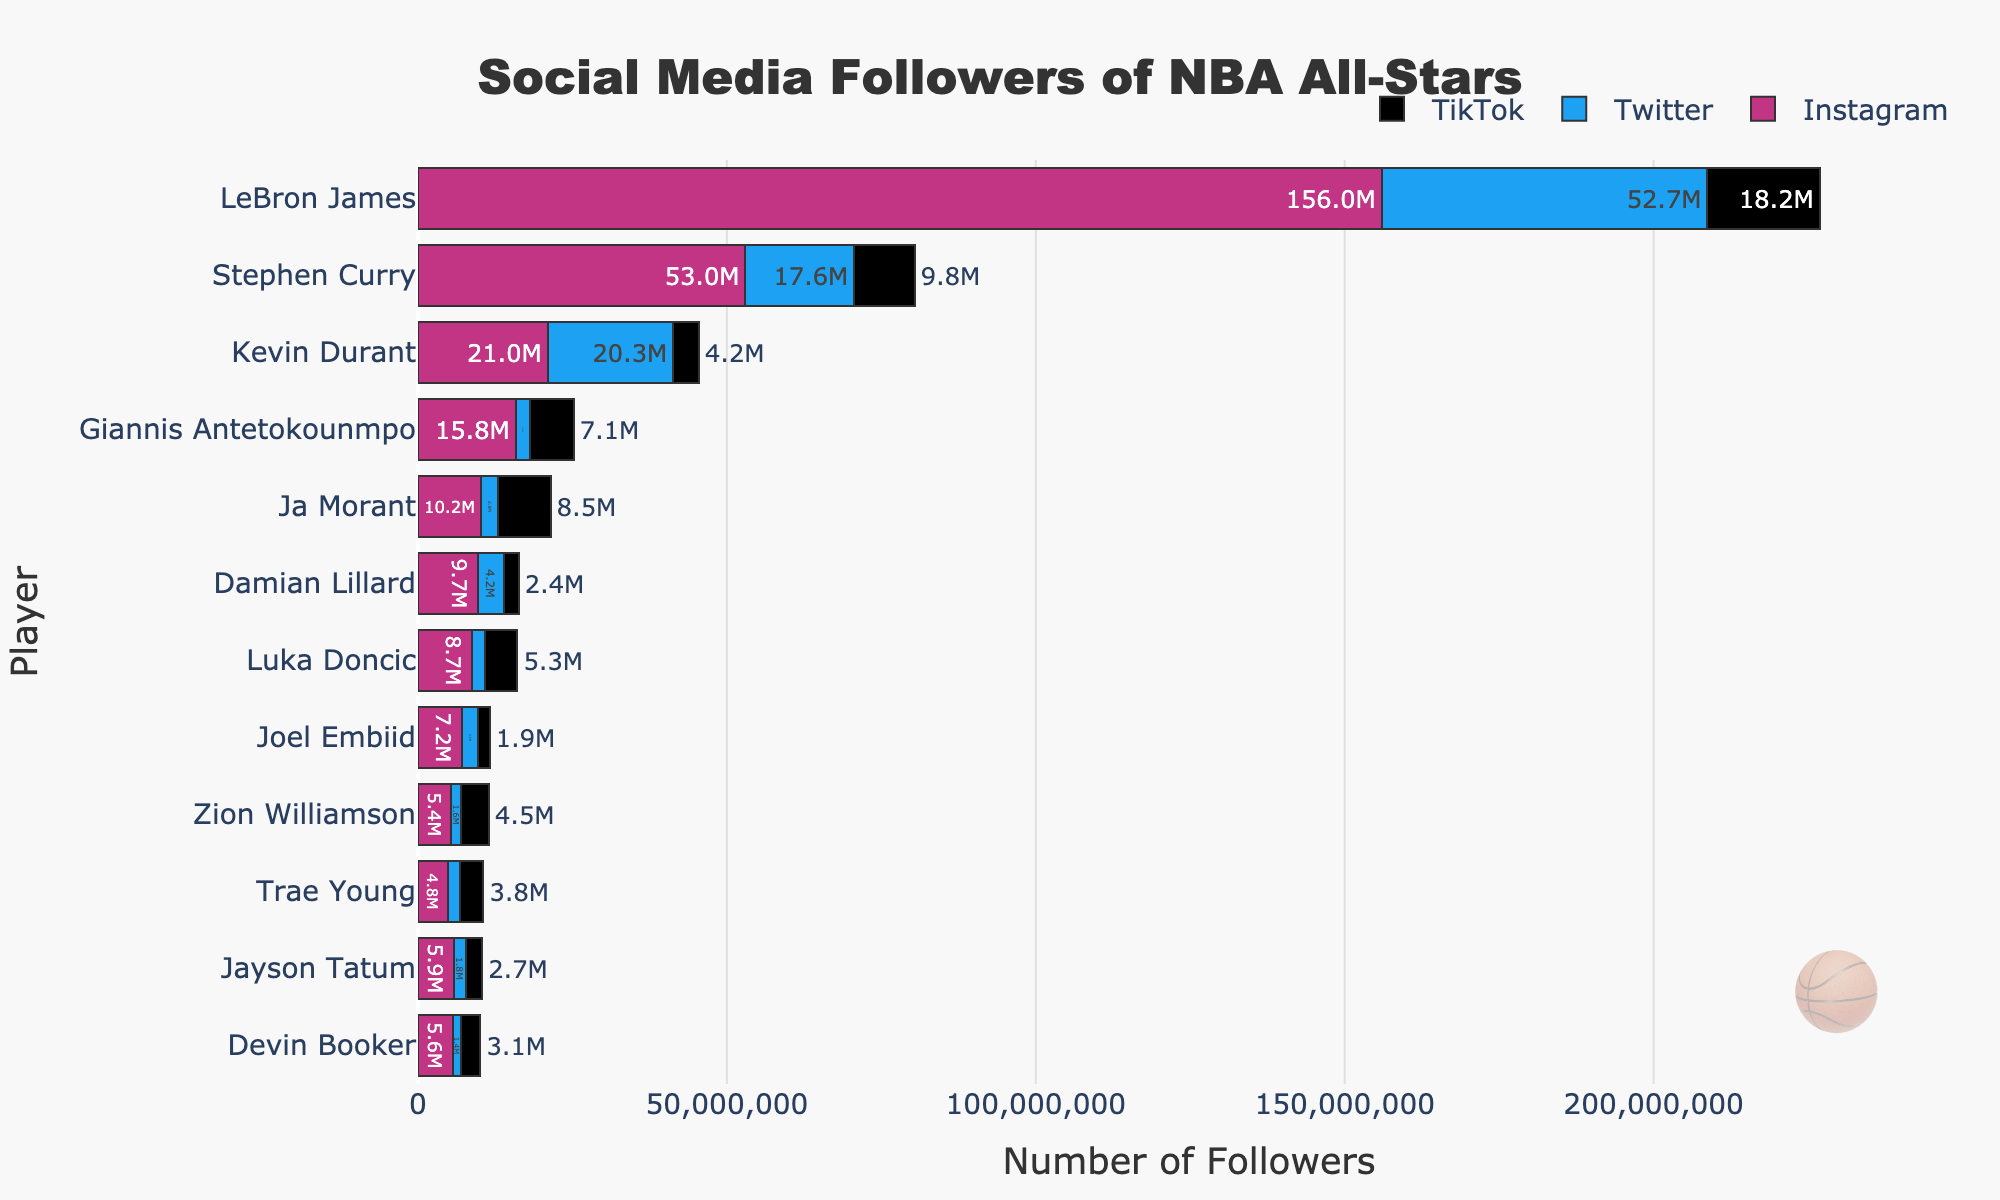What player has the most Instagram followers? LeBron James has the highest bar for Instagram, easily identified as the longest purple bar in the figure. This means he has the most followers on Instagram.
Answer: LeBron James Who has more total followers, Stephen Curry or Kevin Durant? To compare total followers, sum the followers across all platforms for each player. Stephen Curry: 53M + 17.6M + 9.8M = 80.4M. Kevin Durant: 21M + 20.3M + 4.2M = 45.5M. So, Stephen Curry has more total followers.
Answer: Stephen Curry What's the difference in TikTok followers between LeBron James and the player with the second most TikTok followers? LeBron James has 18.2M TikTok followers, and Stephen Curry follows with 9.8M. The difference is 18.2M - 9.8M = 8.4M.
Answer: 8.4M What is the combined total number of Twitter followers for Jayson Tatum and Damian Lillard? Jayson Tatum has 1.8M Twitter followers, and Damian Lillard has 4.2M. Their combined total is 1.8M + 4.2M = 6.0M.
Answer: 6.0M Which player has the least Instagram followers? Zion Williamson has the smallest bar for Instagram followers, indicating he has the least.
Answer: Zion Williamson Among the players who have more followers on Instagram than Twitter, who has the smallest difference between the two platforms? Calculate the difference for each player:
LeBron James: 156M - 52.7M = 103.3M
Stephen Curry: 53M - 17.6M = 35.4M
Kevin Durant: 21M - 20.3M = 0.7M
Giannis Antetokounmpo: 15.8M - 2.3M = 13.5M
Ja Morant: 10.2M - 2.8M = 7.4M
Luka Doncic: 8.7M - 2.1M = 6.6M
Joel Embiid: 7.2M - 2.5M = 4.7M
Jayson Tatum: 5.9M - 1.8M = 4.1M
Devin Booker: 5.6M - 1.4M = 4.2M
Zion Williamson: 5.4M - 1.6M = 3.8M
Trae Young: 4.8M - 2M = 2.8M
Damian Lillard: 9.7M - 4.2M = 5.5M
Kevin Durant has the smallest difference.
Answer: Kevin Durant Between Damian Lillard and Trae Young, who has more followers on TikTok? Damian Lillard has 2.4M TikTok followers while Trae Young has 3.8M. So, Trae Young has more followers on TikTok.
Answer: Trae Young For LeBron James and Stephen Curry, what percentage of their total followers comes from Instagram? LeBron James: Total followers = 156M + 52.7M + 18.2M = 226.9M
Instagram percentage: (156M / 226.9M) * 100 = 68.8%
Stephen Curry: Total followers = 53M + 17.6M + 9.8M = 80.4M
Instagram percentage: (53M / 80.4M) * 100 = 65.9%
LeBron James has approximately 68.8% of his followers from Instagram while Stephen Curry has approximately 65.9%.
Answer: LeBron James: 68.8%, Stephen Curry: 65.9% What is the total number of TikTok followers for all the players shown in the chart? Sum all the TikTok followers: 18.2M + 9.8M + 4.2M + 7.1M + 8.5M + 5.3M + 1.9M + 2.7M + 3.1M + 4.5M + 3.8M + 2.4M = 71.5M.
Answer: 71.5M 